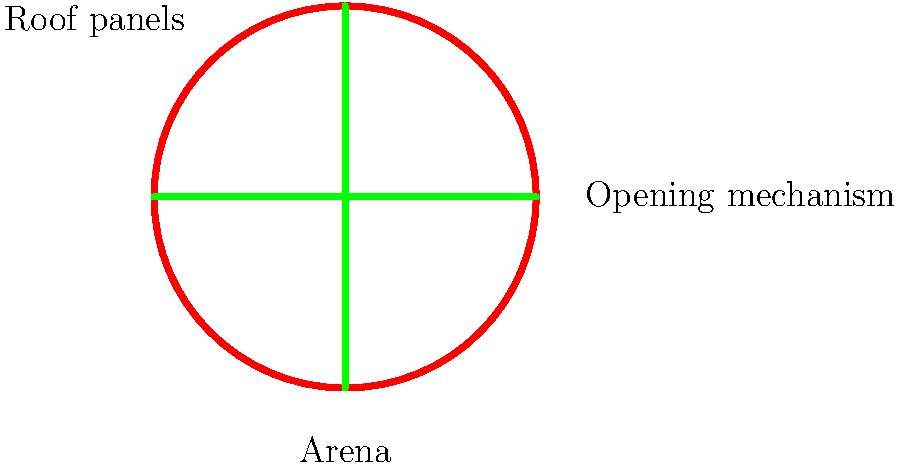In designing a retractable roof system for an outdoor beauty pageant arena, which mechanism would be most suitable for smooth operation and minimal interference with the spectators' view during the opening and closing process? To design an effective retractable roof system for a beauty pageant arena, we need to consider several factors:

1. Aesthetics: The roof should complement the arena's design and not detract from the pageant's visual appeal.

2. Functionality: The mechanism should allow for quick and smooth opening/closing.

3. Minimal obstruction: The system should not interfere with spectators' views during operation.

4. Weather protection: When closed, the roof should provide adequate protection from various weather conditions.

5. Maintenance: The system should be easy to maintain and repair.

Considering these factors, the most suitable mechanism would be a radial folding system:

1. The roof is divided into pie-shaped sections that fold and unfold radially.

2. Each section is connected to a central hub and guided by tracks along the arena's perimeter.

3. The sections overlap slightly when closed to ensure weatherproofing.

4. When opening, the sections fold and stack neatly at the arena's edge, minimizing view obstruction.

5. The radial design allows for a symmetrical and aesthetically pleasing appearance, fitting for a beauty pageant venue.

6. The folding mechanism can be motorized for smooth and quick operation.

7. This design distributes the weight evenly, reducing stress on the structure.

8. Maintenance access is relatively easy as the mechanism is along the arena's perimeter.

This radial folding system provides an elegant solution that meets both the functional and aesthetic requirements of a beauty pageant arena.
Answer: Radial folding system 